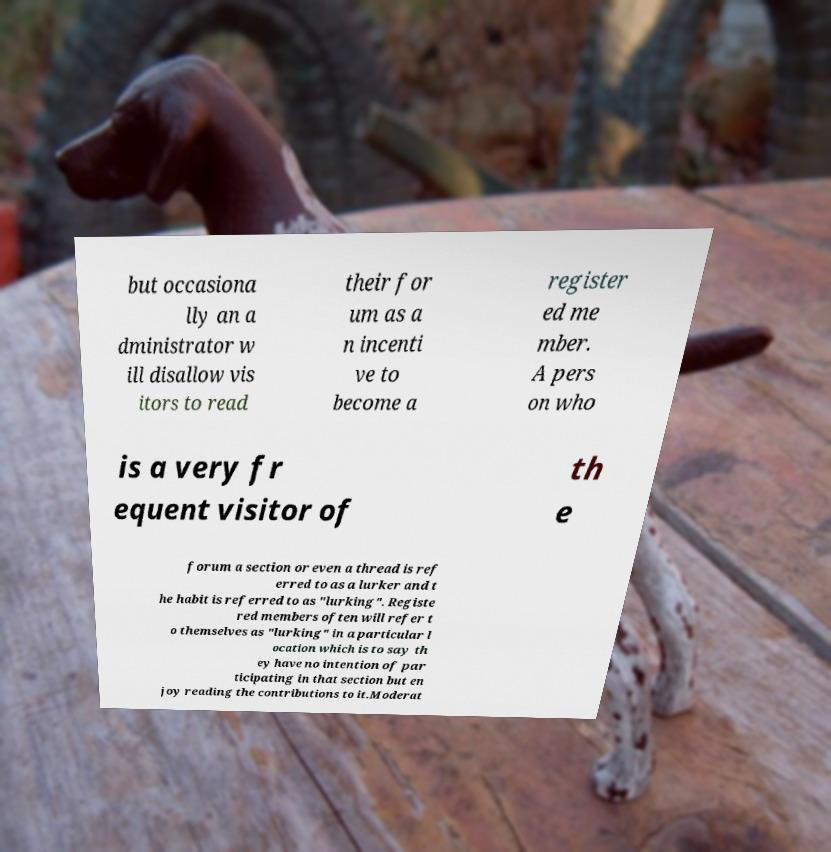Please identify and transcribe the text found in this image. but occasiona lly an a dministrator w ill disallow vis itors to read their for um as a n incenti ve to become a register ed me mber. A pers on who is a very fr equent visitor of th e forum a section or even a thread is ref erred to as a lurker and t he habit is referred to as "lurking". Registe red members often will refer t o themselves as "lurking" in a particular l ocation which is to say th ey have no intention of par ticipating in that section but en joy reading the contributions to it.Moderat 